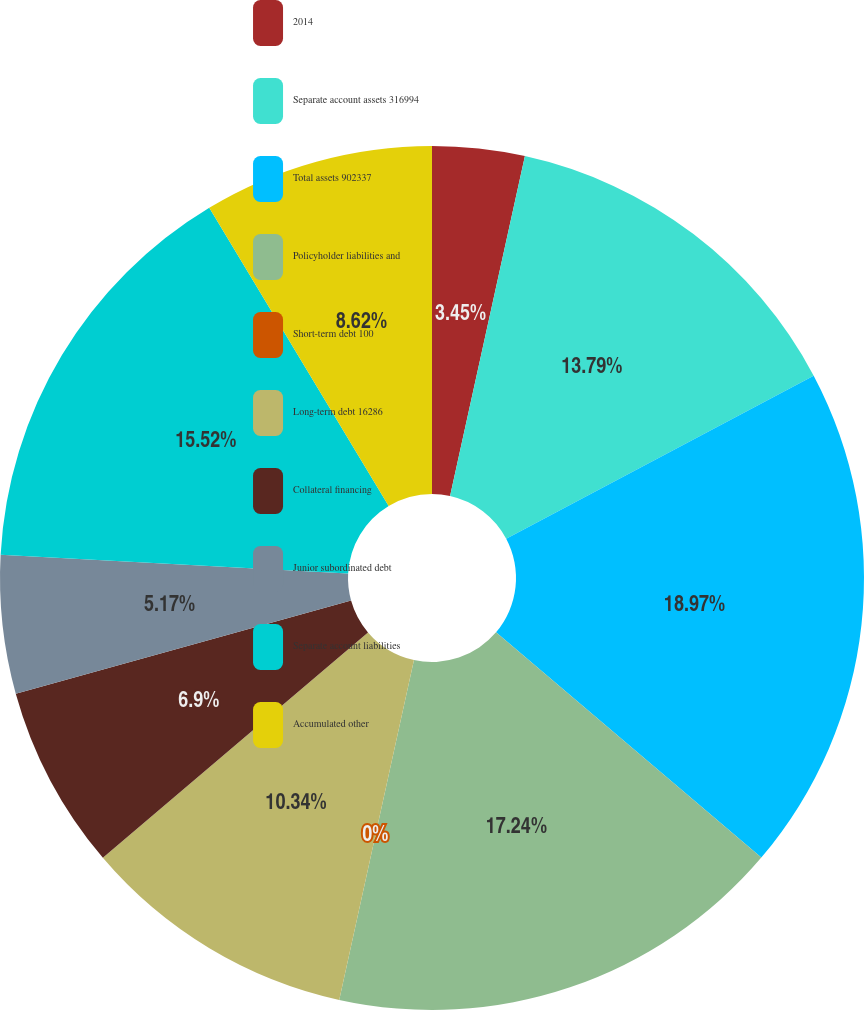Convert chart. <chart><loc_0><loc_0><loc_500><loc_500><pie_chart><fcel>2014<fcel>Separate account assets 316994<fcel>Total assets 902337<fcel>Policyholder liabilities and<fcel>Short-term debt 100<fcel>Long-term debt 16286<fcel>Collateral financing<fcel>Junior subordinated debt<fcel>Separate account liabilities<fcel>Accumulated other<nl><fcel>3.45%<fcel>13.79%<fcel>18.96%<fcel>17.24%<fcel>0.0%<fcel>10.34%<fcel>6.9%<fcel>5.17%<fcel>15.52%<fcel>8.62%<nl></chart> 